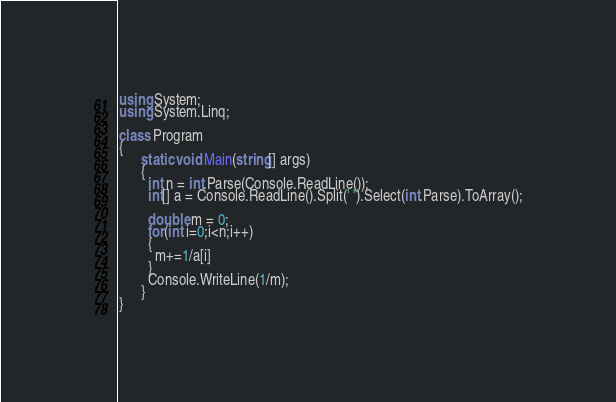Convert code to text. <code><loc_0><loc_0><loc_500><loc_500><_C#_>using System;
using System.Linq;

class Program
{
      static void Main(string[] args)
      {
        int n = int.Parse(Console.ReadLine());
        int[] a = Console.ReadLine().Split(' ').Select(int.Parse).ToArray();
        
        double m = 0;
        for(int i=0;i<n;i++)
        {
          m+=1/a[i]
        }
        Console.WriteLine(1/m);
      }
}
</code> 